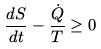Convert formula to latex. <formula><loc_0><loc_0><loc_500><loc_500>\frac { d S } { d t } - \frac { \dot { Q } } { T } \geq 0</formula> 